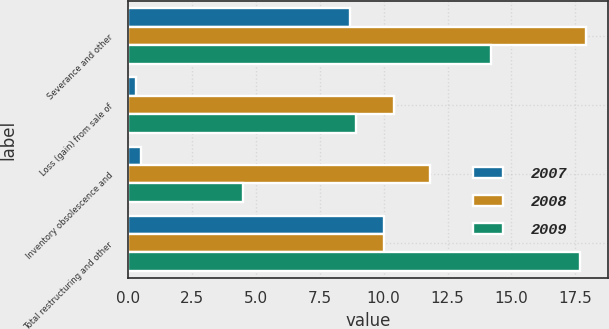Convert chart. <chart><loc_0><loc_0><loc_500><loc_500><stacked_bar_chart><ecel><fcel>Severance and other<fcel>Loss (gain) from sale of<fcel>Inventory obsolescence and<fcel>Total restructuring and other<nl><fcel>2007<fcel>8.7<fcel>0.3<fcel>0.5<fcel>10<nl><fcel>2008<fcel>17.9<fcel>10.4<fcel>11.8<fcel>10<nl><fcel>2009<fcel>14.2<fcel>8.9<fcel>4.5<fcel>17.7<nl></chart> 